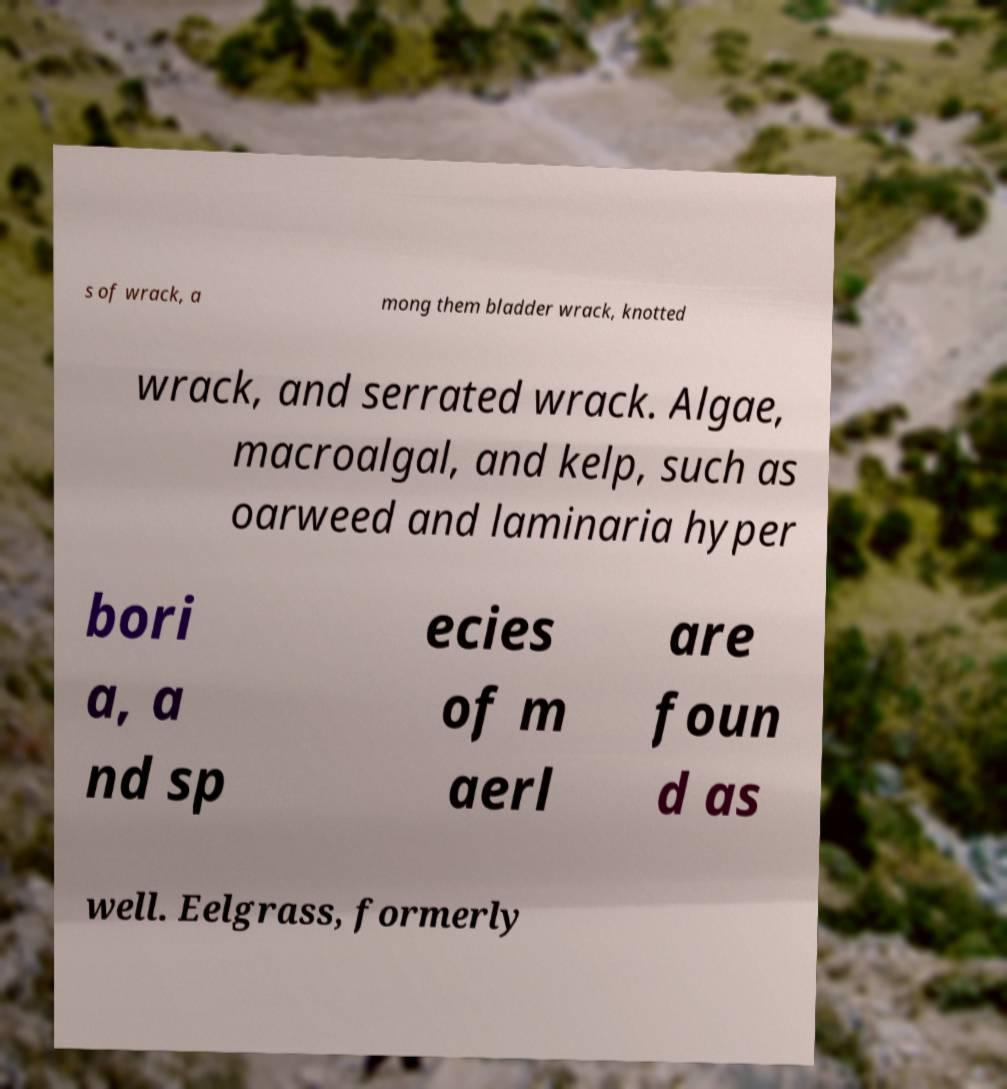Could you assist in decoding the text presented in this image and type it out clearly? s of wrack, a mong them bladder wrack, knotted wrack, and serrated wrack. Algae, macroalgal, and kelp, such as oarweed and laminaria hyper bori a, a nd sp ecies of m aerl are foun d as well. Eelgrass, formerly 